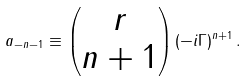Convert formula to latex. <formula><loc_0><loc_0><loc_500><loc_500>a _ { - n - 1 } \equiv \begin{pmatrix} r \\ n + 1 \end{pmatrix} ( - i \Gamma ) ^ { n + 1 } \, .</formula> 